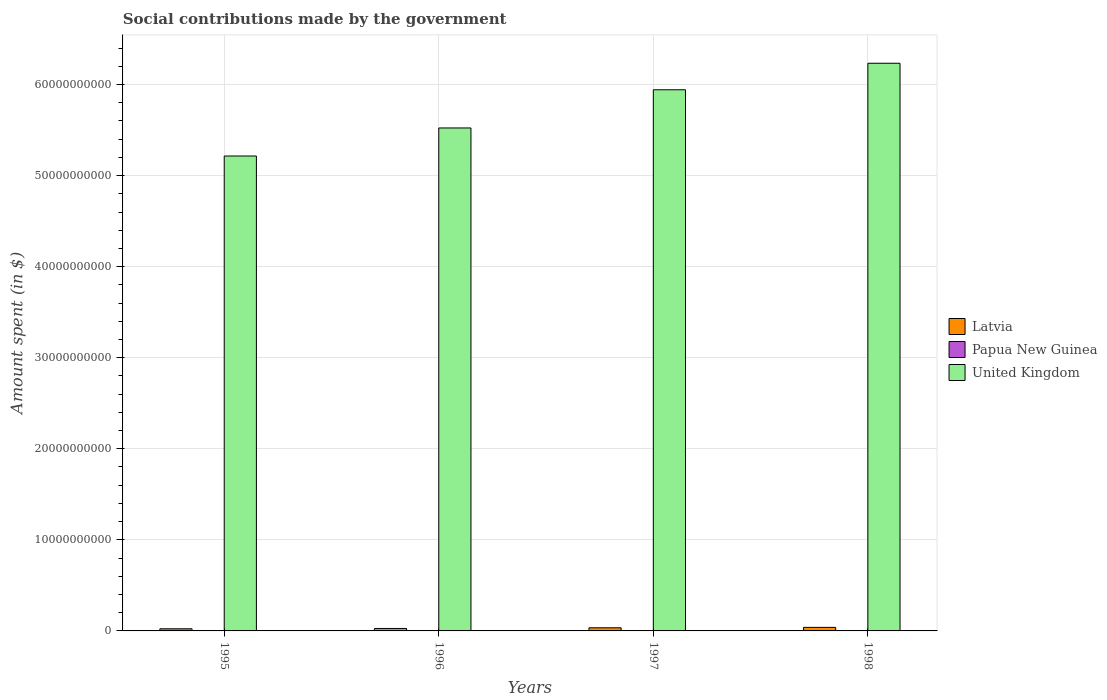How many different coloured bars are there?
Offer a very short reply. 3. Are the number of bars on each tick of the X-axis equal?
Make the answer very short. Yes. What is the label of the 1st group of bars from the left?
Your response must be concise. 1995. In how many cases, is the number of bars for a given year not equal to the number of legend labels?
Provide a succinct answer. 0. What is the amount spent on social contributions in Papua New Guinea in 1996?
Provide a succinct answer. 7.87e+06. Across all years, what is the maximum amount spent on social contributions in Latvia?
Your answer should be very brief. 3.90e+08. Across all years, what is the minimum amount spent on social contributions in Latvia?
Your answer should be compact. 2.34e+08. In which year was the amount spent on social contributions in Latvia maximum?
Your answer should be compact. 1998. What is the total amount spent on social contributions in Latvia in the graph?
Make the answer very short. 1.24e+09. What is the difference between the amount spent on social contributions in Papua New Guinea in 1995 and that in 1998?
Give a very brief answer. 2.64e+06. What is the difference between the amount spent on social contributions in United Kingdom in 1997 and the amount spent on social contributions in Papua New Guinea in 1995?
Your answer should be compact. 5.94e+1. What is the average amount spent on social contributions in Papua New Guinea per year?
Provide a short and direct response. 6.40e+06. In the year 1996, what is the difference between the amount spent on social contributions in Papua New Guinea and amount spent on social contributions in Latvia?
Keep it short and to the point. -2.63e+08. In how many years, is the amount spent on social contributions in Papua New Guinea greater than 60000000000 $?
Keep it short and to the point. 0. What is the ratio of the amount spent on social contributions in United Kingdom in 1995 to that in 1996?
Your response must be concise. 0.94. Is the difference between the amount spent on social contributions in Papua New Guinea in 1996 and 1998 greater than the difference between the amount spent on social contributions in Latvia in 1996 and 1998?
Give a very brief answer. Yes. What is the difference between the highest and the second highest amount spent on social contributions in United Kingdom?
Keep it short and to the point. 2.91e+09. What is the difference between the highest and the lowest amount spent on social contributions in Latvia?
Provide a short and direct response. 1.56e+08. Is the sum of the amount spent on social contributions in Latvia in 1995 and 1997 greater than the maximum amount spent on social contributions in Papua New Guinea across all years?
Ensure brevity in your answer.  Yes. What does the 2nd bar from the left in 1998 represents?
Make the answer very short. Papua New Guinea. What does the 2nd bar from the right in 1998 represents?
Provide a short and direct response. Papua New Guinea. Are all the bars in the graph horizontal?
Give a very brief answer. No. Are the values on the major ticks of Y-axis written in scientific E-notation?
Make the answer very short. No. Does the graph contain grids?
Offer a very short reply. Yes. How are the legend labels stacked?
Provide a succinct answer. Vertical. What is the title of the graph?
Your response must be concise. Social contributions made by the government. What is the label or title of the Y-axis?
Ensure brevity in your answer.  Amount spent (in $). What is the Amount spent (in $) in Latvia in 1995?
Offer a very short reply. 2.34e+08. What is the Amount spent (in $) of Papua New Guinea in 1995?
Make the answer very short. 7.29e+06. What is the Amount spent (in $) in United Kingdom in 1995?
Your answer should be compact. 5.21e+1. What is the Amount spent (in $) in Latvia in 1996?
Your response must be concise. 2.71e+08. What is the Amount spent (in $) in Papua New Guinea in 1996?
Offer a terse response. 7.87e+06. What is the Amount spent (in $) of United Kingdom in 1996?
Provide a succinct answer. 5.52e+1. What is the Amount spent (in $) in Latvia in 1997?
Keep it short and to the point. 3.43e+08. What is the Amount spent (in $) of Papua New Guinea in 1997?
Your response must be concise. 5.77e+06. What is the Amount spent (in $) in United Kingdom in 1997?
Make the answer very short. 5.94e+1. What is the Amount spent (in $) of Latvia in 1998?
Provide a short and direct response. 3.90e+08. What is the Amount spent (in $) in Papua New Guinea in 1998?
Your answer should be very brief. 4.65e+06. What is the Amount spent (in $) in United Kingdom in 1998?
Your response must be concise. 6.23e+1. Across all years, what is the maximum Amount spent (in $) in Latvia?
Keep it short and to the point. 3.90e+08. Across all years, what is the maximum Amount spent (in $) in Papua New Guinea?
Your response must be concise. 7.87e+06. Across all years, what is the maximum Amount spent (in $) in United Kingdom?
Provide a short and direct response. 6.23e+1. Across all years, what is the minimum Amount spent (in $) in Latvia?
Give a very brief answer. 2.34e+08. Across all years, what is the minimum Amount spent (in $) in Papua New Guinea?
Your response must be concise. 4.65e+06. Across all years, what is the minimum Amount spent (in $) of United Kingdom?
Your answer should be compact. 5.21e+1. What is the total Amount spent (in $) in Latvia in the graph?
Ensure brevity in your answer.  1.24e+09. What is the total Amount spent (in $) of Papua New Guinea in the graph?
Offer a very short reply. 2.56e+07. What is the total Amount spent (in $) of United Kingdom in the graph?
Ensure brevity in your answer.  2.29e+11. What is the difference between the Amount spent (in $) in Latvia in 1995 and that in 1996?
Your answer should be compact. -3.70e+07. What is the difference between the Amount spent (in $) in Papua New Guinea in 1995 and that in 1996?
Offer a very short reply. -5.87e+05. What is the difference between the Amount spent (in $) of United Kingdom in 1995 and that in 1996?
Offer a terse response. -3.08e+09. What is the difference between the Amount spent (in $) in Latvia in 1995 and that in 1997?
Give a very brief answer. -1.10e+08. What is the difference between the Amount spent (in $) of Papua New Guinea in 1995 and that in 1997?
Offer a terse response. 1.52e+06. What is the difference between the Amount spent (in $) in United Kingdom in 1995 and that in 1997?
Provide a short and direct response. -7.27e+09. What is the difference between the Amount spent (in $) of Latvia in 1995 and that in 1998?
Make the answer very short. -1.56e+08. What is the difference between the Amount spent (in $) of Papua New Guinea in 1995 and that in 1998?
Your response must be concise. 2.64e+06. What is the difference between the Amount spent (in $) in United Kingdom in 1995 and that in 1998?
Offer a very short reply. -1.02e+1. What is the difference between the Amount spent (in $) of Latvia in 1996 and that in 1997?
Provide a succinct answer. -7.25e+07. What is the difference between the Amount spent (in $) of Papua New Guinea in 1996 and that in 1997?
Provide a succinct answer. 2.10e+06. What is the difference between the Amount spent (in $) in United Kingdom in 1996 and that in 1997?
Offer a terse response. -4.19e+09. What is the difference between the Amount spent (in $) in Latvia in 1996 and that in 1998?
Your answer should be very brief. -1.19e+08. What is the difference between the Amount spent (in $) of Papua New Guinea in 1996 and that in 1998?
Give a very brief answer. 3.22e+06. What is the difference between the Amount spent (in $) of United Kingdom in 1996 and that in 1998?
Give a very brief answer. -7.10e+09. What is the difference between the Amount spent (in $) in Latvia in 1997 and that in 1998?
Your answer should be compact. -4.62e+07. What is the difference between the Amount spent (in $) in Papua New Guinea in 1997 and that in 1998?
Keep it short and to the point. 1.12e+06. What is the difference between the Amount spent (in $) in United Kingdom in 1997 and that in 1998?
Keep it short and to the point. -2.91e+09. What is the difference between the Amount spent (in $) in Latvia in 1995 and the Amount spent (in $) in Papua New Guinea in 1996?
Keep it short and to the point. 2.26e+08. What is the difference between the Amount spent (in $) of Latvia in 1995 and the Amount spent (in $) of United Kingdom in 1996?
Your answer should be compact. -5.50e+1. What is the difference between the Amount spent (in $) in Papua New Guinea in 1995 and the Amount spent (in $) in United Kingdom in 1996?
Your answer should be very brief. -5.52e+1. What is the difference between the Amount spent (in $) of Latvia in 1995 and the Amount spent (in $) of Papua New Guinea in 1997?
Offer a terse response. 2.28e+08. What is the difference between the Amount spent (in $) in Latvia in 1995 and the Amount spent (in $) in United Kingdom in 1997?
Offer a terse response. -5.92e+1. What is the difference between the Amount spent (in $) in Papua New Guinea in 1995 and the Amount spent (in $) in United Kingdom in 1997?
Offer a terse response. -5.94e+1. What is the difference between the Amount spent (in $) in Latvia in 1995 and the Amount spent (in $) in Papua New Guinea in 1998?
Offer a terse response. 2.29e+08. What is the difference between the Amount spent (in $) of Latvia in 1995 and the Amount spent (in $) of United Kingdom in 1998?
Ensure brevity in your answer.  -6.21e+1. What is the difference between the Amount spent (in $) in Papua New Guinea in 1995 and the Amount spent (in $) in United Kingdom in 1998?
Offer a terse response. -6.23e+1. What is the difference between the Amount spent (in $) in Latvia in 1996 and the Amount spent (in $) in Papua New Guinea in 1997?
Provide a succinct answer. 2.65e+08. What is the difference between the Amount spent (in $) of Latvia in 1996 and the Amount spent (in $) of United Kingdom in 1997?
Ensure brevity in your answer.  -5.92e+1. What is the difference between the Amount spent (in $) in Papua New Guinea in 1996 and the Amount spent (in $) in United Kingdom in 1997?
Ensure brevity in your answer.  -5.94e+1. What is the difference between the Amount spent (in $) in Latvia in 1996 and the Amount spent (in $) in Papua New Guinea in 1998?
Your answer should be compact. 2.66e+08. What is the difference between the Amount spent (in $) of Latvia in 1996 and the Amount spent (in $) of United Kingdom in 1998?
Your answer should be very brief. -6.21e+1. What is the difference between the Amount spent (in $) in Papua New Guinea in 1996 and the Amount spent (in $) in United Kingdom in 1998?
Offer a terse response. -6.23e+1. What is the difference between the Amount spent (in $) in Latvia in 1997 and the Amount spent (in $) in Papua New Guinea in 1998?
Your response must be concise. 3.39e+08. What is the difference between the Amount spent (in $) in Latvia in 1997 and the Amount spent (in $) in United Kingdom in 1998?
Your answer should be compact. -6.20e+1. What is the difference between the Amount spent (in $) of Papua New Guinea in 1997 and the Amount spent (in $) of United Kingdom in 1998?
Offer a terse response. -6.23e+1. What is the average Amount spent (in $) of Latvia per year?
Your answer should be very brief. 3.10e+08. What is the average Amount spent (in $) of Papua New Guinea per year?
Your answer should be compact. 6.40e+06. What is the average Amount spent (in $) of United Kingdom per year?
Your response must be concise. 5.73e+1. In the year 1995, what is the difference between the Amount spent (in $) of Latvia and Amount spent (in $) of Papua New Guinea?
Ensure brevity in your answer.  2.27e+08. In the year 1995, what is the difference between the Amount spent (in $) in Latvia and Amount spent (in $) in United Kingdom?
Your answer should be compact. -5.19e+1. In the year 1995, what is the difference between the Amount spent (in $) in Papua New Guinea and Amount spent (in $) in United Kingdom?
Ensure brevity in your answer.  -5.21e+1. In the year 1996, what is the difference between the Amount spent (in $) of Latvia and Amount spent (in $) of Papua New Guinea?
Provide a short and direct response. 2.63e+08. In the year 1996, what is the difference between the Amount spent (in $) of Latvia and Amount spent (in $) of United Kingdom?
Make the answer very short. -5.50e+1. In the year 1996, what is the difference between the Amount spent (in $) of Papua New Guinea and Amount spent (in $) of United Kingdom?
Keep it short and to the point. -5.52e+1. In the year 1997, what is the difference between the Amount spent (in $) of Latvia and Amount spent (in $) of Papua New Guinea?
Your response must be concise. 3.38e+08. In the year 1997, what is the difference between the Amount spent (in $) in Latvia and Amount spent (in $) in United Kingdom?
Give a very brief answer. -5.91e+1. In the year 1997, what is the difference between the Amount spent (in $) in Papua New Guinea and Amount spent (in $) in United Kingdom?
Ensure brevity in your answer.  -5.94e+1. In the year 1998, what is the difference between the Amount spent (in $) of Latvia and Amount spent (in $) of Papua New Guinea?
Make the answer very short. 3.85e+08. In the year 1998, what is the difference between the Amount spent (in $) of Latvia and Amount spent (in $) of United Kingdom?
Provide a short and direct response. -6.19e+1. In the year 1998, what is the difference between the Amount spent (in $) of Papua New Guinea and Amount spent (in $) of United Kingdom?
Ensure brevity in your answer.  -6.23e+1. What is the ratio of the Amount spent (in $) in Latvia in 1995 to that in 1996?
Give a very brief answer. 0.86. What is the ratio of the Amount spent (in $) of Papua New Guinea in 1995 to that in 1996?
Provide a succinct answer. 0.93. What is the ratio of the Amount spent (in $) of United Kingdom in 1995 to that in 1996?
Your answer should be very brief. 0.94. What is the ratio of the Amount spent (in $) of Latvia in 1995 to that in 1997?
Ensure brevity in your answer.  0.68. What is the ratio of the Amount spent (in $) of Papua New Guinea in 1995 to that in 1997?
Ensure brevity in your answer.  1.26. What is the ratio of the Amount spent (in $) of United Kingdom in 1995 to that in 1997?
Your answer should be very brief. 0.88. What is the ratio of the Amount spent (in $) in Latvia in 1995 to that in 1998?
Offer a terse response. 0.6. What is the ratio of the Amount spent (in $) in Papua New Guinea in 1995 to that in 1998?
Offer a very short reply. 1.57. What is the ratio of the Amount spent (in $) in United Kingdom in 1995 to that in 1998?
Provide a succinct answer. 0.84. What is the ratio of the Amount spent (in $) in Latvia in 1996 to that in 1997?
Offer a terse response. 0.79. What is the ratio of the Amount spent (in $) of Papua New Guinea in 1996 to that in 1997?
Make the answer very short. 1.36. What is the ratio of the Amount spent (in $) of United Kingdom in 1996 to that in 1997?
Keep it short and to the point. 0.93. What is the ratio of the Amount spent (in $) in Latvia in 1996 to that in 1998?
Provide a short and direct response. 0.7. What is the ratio of the Amount spent (in $) in Papua New Guinea in 1996 to that in 1998?
Ensure brevity in your answer.  1.69. What is the ratio of the Amount spent (in $) in United Kingdom in 1996 to that in 1998?
Your response must be concise. 0.89. What is the ratio of the Amount spent (in $) in Latvia in 1997 to that in 1998?
Your answer should be compact. 0.88. What is the ratio of the Amount spent (in $) of Papua New Guinea in 1997 to that in 1998?
Your response must be concise. 1.24. What is the ratio of the Amount spent (in $) of United Kingdom in 1997 to that in 1998?
Offer a very short reply. 0.95. What is the difference between the highest and the second highest Amount spent (in $) in Latvia?
Your response must be concise. 4.62e+07. What is the difference between the highest and the second highest Amount spent (in $) of Papua New Guinea?
Provide a succinct answer. 5.87e+05. What is the difference between the highest and the second highest Amount spent (in $) in United Kingdom?
Your answer should be compact. 2.91e+09. What is the difference between the highest and the lowest Amount spent (in $) of Latvia?
Give a very brief answer. 1.56e+08. What is the difference between the highest and the lowest Amount spent (in $) of Papua New Guinea?
Your answer should be compact. 3.22e+06. What is the difference between the highest and the lowest Amount spent (in $) in United Kingdom?
Give a very brief answer. 1.02e+1. 